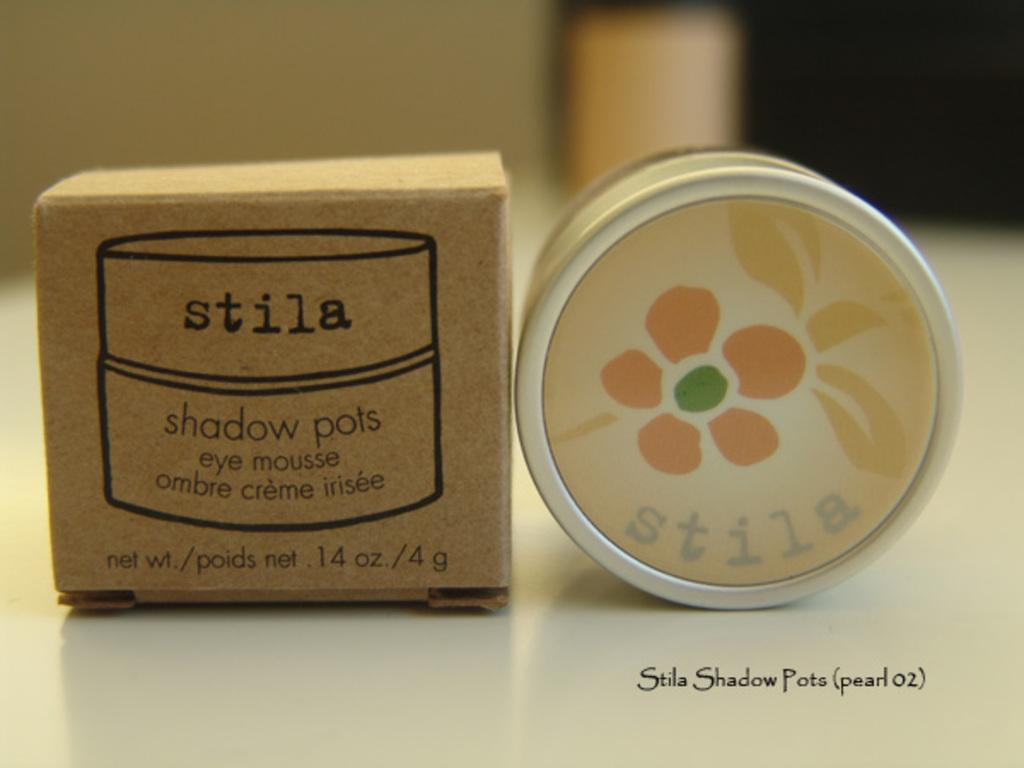Provide a one-sentence caption for the provided image. a brown box that says stila at the top of it. 